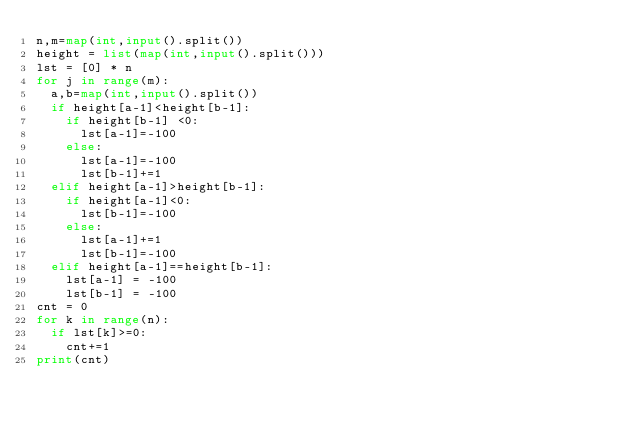<code> <loc_0><loc_0><loc_500><loc_500><_Python_>n,m=map(int,input().split())
height = list(map(int,input().split()))
lst = [0] * n
for j in range(m):
  a,b=map(int,input().split())
  if height[a-1]<height[b-1]:
    if height[b-1] <0:
      lst[a-1]=-100
    else:
      lst[a-1]=-100
      lst[b-1]+=1
  elif height[a-1]>height[b-1]:
    if height[a-1]<0:
      lst[b-1]=-100
    else:
      lst[a-1]+=1
      lst[b-1]=-100
  elif height[a-1]==height[b-1]:
    lst[a-1] = -100
    lst[b-1] = -100
cnt = 0
for k in range(n):
  if lst[k]>=0:
    cnt+=1
print(cnt)</code> 